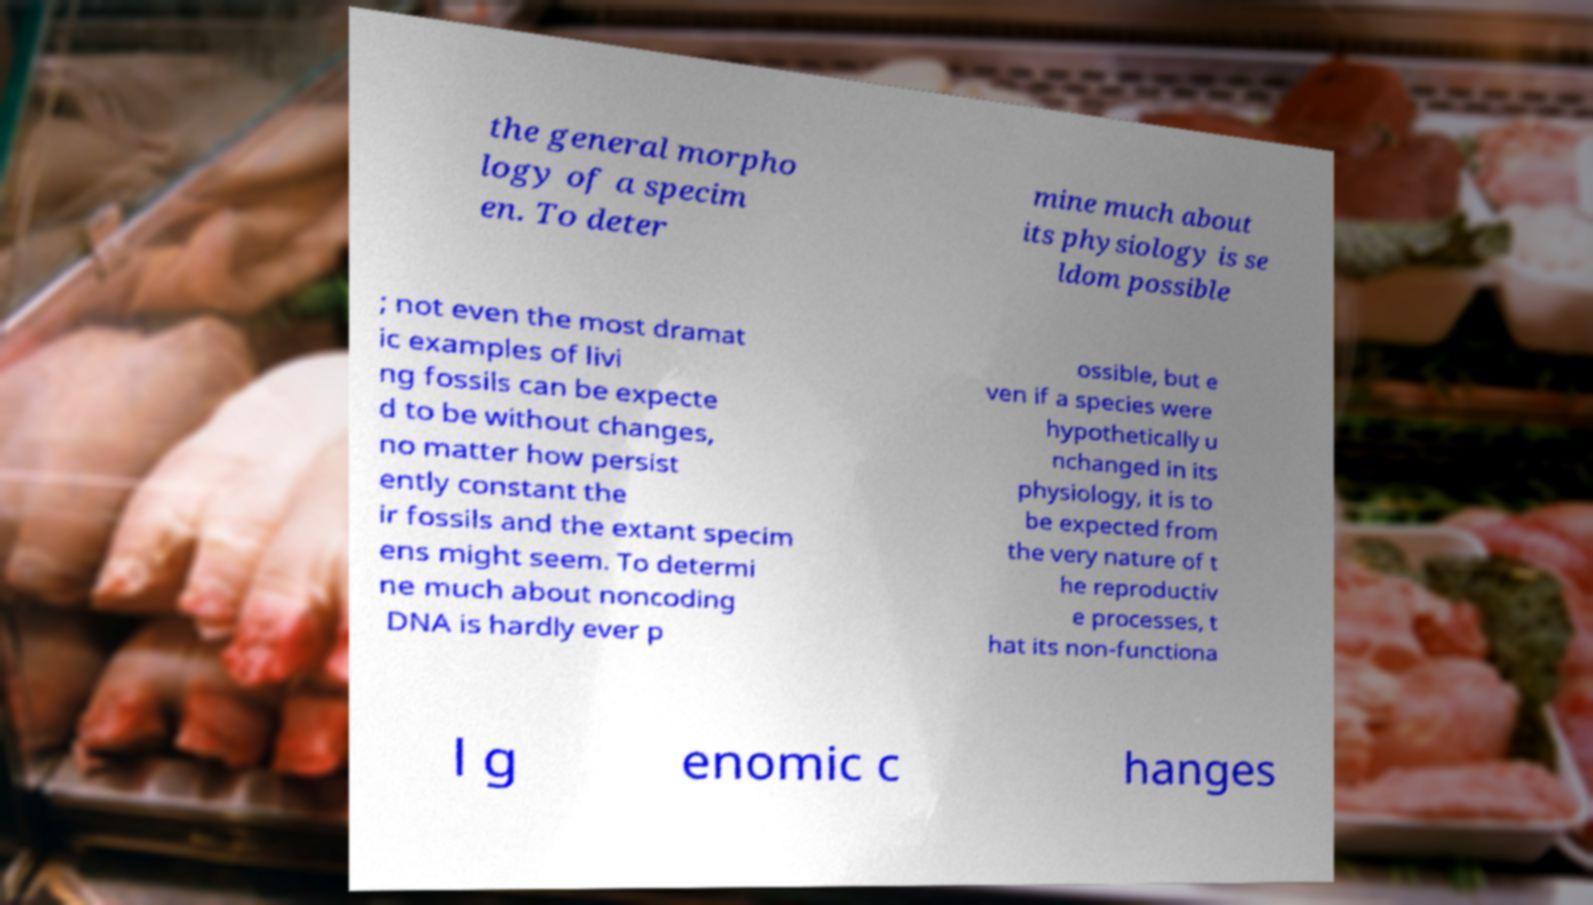Could you assist in decoding the text presented in this image and type it out clearly? the general morpho logy of a specim en. To deter mine much about its physiology is se ldom possible ; not even the most dramat ic examples of livi ng fossils can be expecte d to be without changes, no matter how persist ently constant the ir fossils and the extant specim ens might seem. To determi ne much about noncoding DNA is hardly ever p ossible, but e ven if a species were hypothetically u nchanged in its physiology, it is to be expected from the very nature of t he reproductiv e processes, t hat its non-functiona l g enomic c hanges 